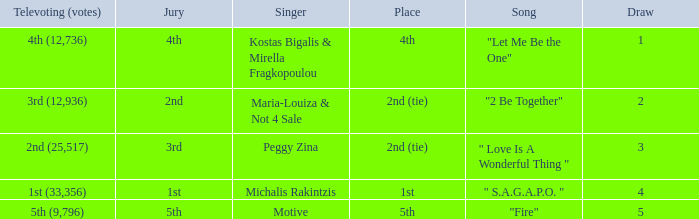Singer Maria-Louiza & Not 4 Sale had what jury? 2nd. 